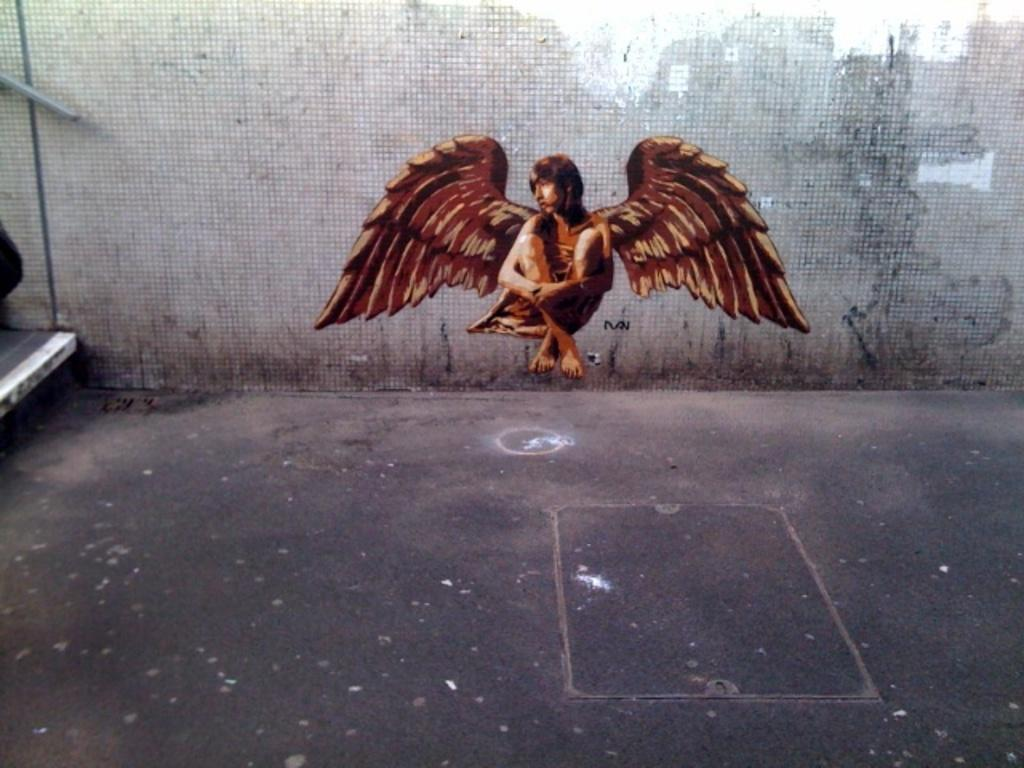What type of character is depicted in the image? There is an animated woman in the image. What distinguishing feature does the woman have? The woman has wings. What can be seen in the background of the image? There is a wall in the image. What hobbies does the animated woman enjoy in the image? There is no information about the woman's hobbies in the image. What sound does the animated woman make in the image? The image is not accompanied by any sound, so it cannot be determined what sound the woman makes. 